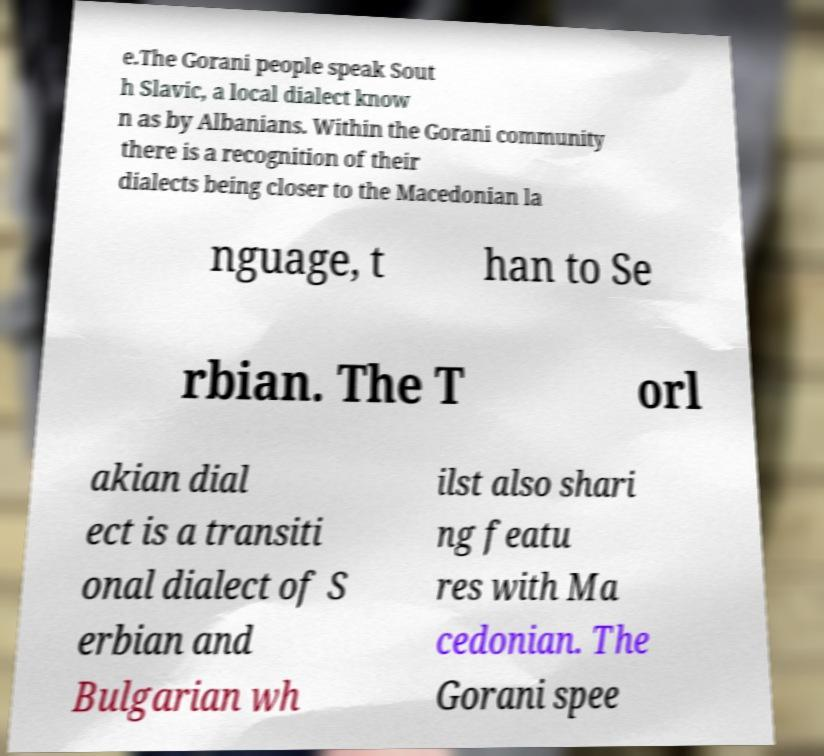There's text embedded in this image that I need extracted. Can you transcribe it verbatim? e.The Gorani people speak Sout h Slavic, a local dialect know n as by Albanians. Within the Gorani community there is a recognition of their dialects being closer to the Macedonian la nguage, t han to Se rbian. The T orl akian dial ect is a transiti onal dialect of S erbian and Bulgarian wh ilst also shari ng featu res with Ma cedonian. The Gorani spee 